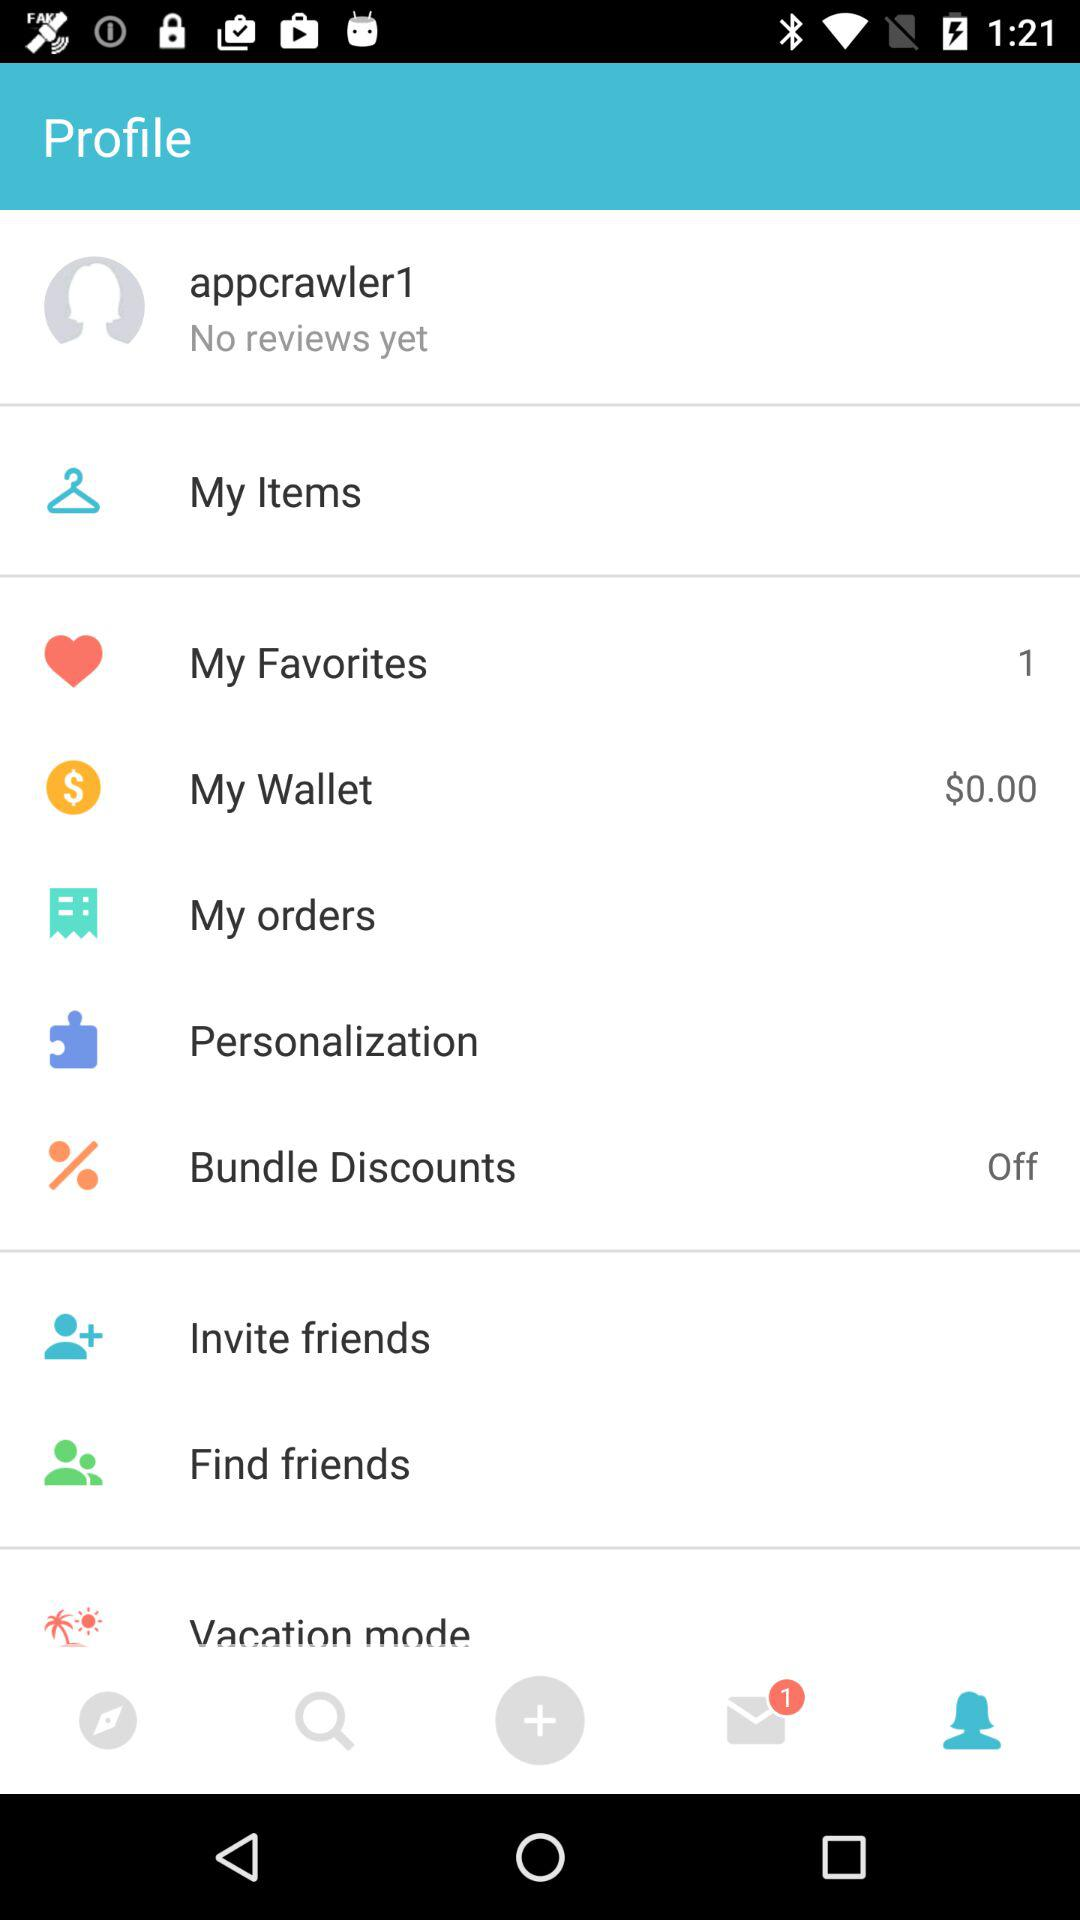Which tab is currently selected? The currently selected tab is "Profile". 